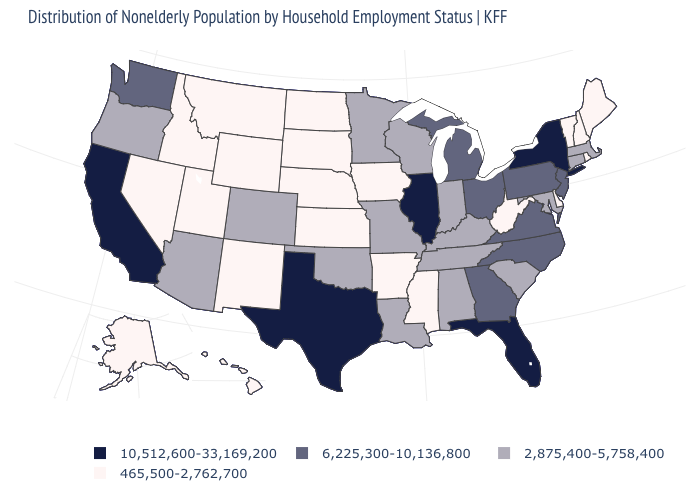What is the highest value in the MidWest ?
Keep it brief. 10,512,600-33,169,200. What is the value of Connecticut?
Write a very short answer. 2,875,400-5,758,400. Is the legend a continuous bar?
Keep it brief. No. Among the states that border Ohio , does West Virginia have the lowest value?
Concise answer only. Yes. Among the states that border Illinois , does Iowa have the highest value?
Give a very brief answer. No. What is the lowest value in the USA?
Concise answer only. 465,500-2,762,700. Among the states that border Mississippi , does Arkansas have the highest value?
Concise answer only. No. What is the value of Iowa?
Write a very short answer. 465,500-2,762,700. How many symbols are there in the legend?
Be succinct. 4. What is the highest value in the USA?
Answer briefly. 10,512,600-33,169,200. Name the states that have a value in the range 2,875,400-5,758,400?
Be succinct. Alabama, Arizona, Colorado, Connecticut, Indiana, Kentucky, Louisiana, Maryland, Massachusetts, Minnesota, Missouri, Oklahoma, Oregon, South Carolina, Tennessee, Wisconsin. Does Tennessee have a lower value than Maryland?
Concise answer only. No. What is the value of New Jersey?
Be succinct. 6,225,300-10,136,800. Among the states that border Nevada , does California have the highest value?
Short answer required. Yes. What is the highest value in states that border Mississippi?
Quick response, please. 2,875,400-5,758,400. 